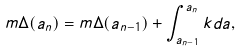<formula> <loc_0><loc_0><loc_500><loc_500>m \Delta ( a _ { n } ) = m \Delta ( a _ { n - 1 } ) + \int _ { a _ { n - 1 } } ^ { a _ { n } } k d a ,</formula> 